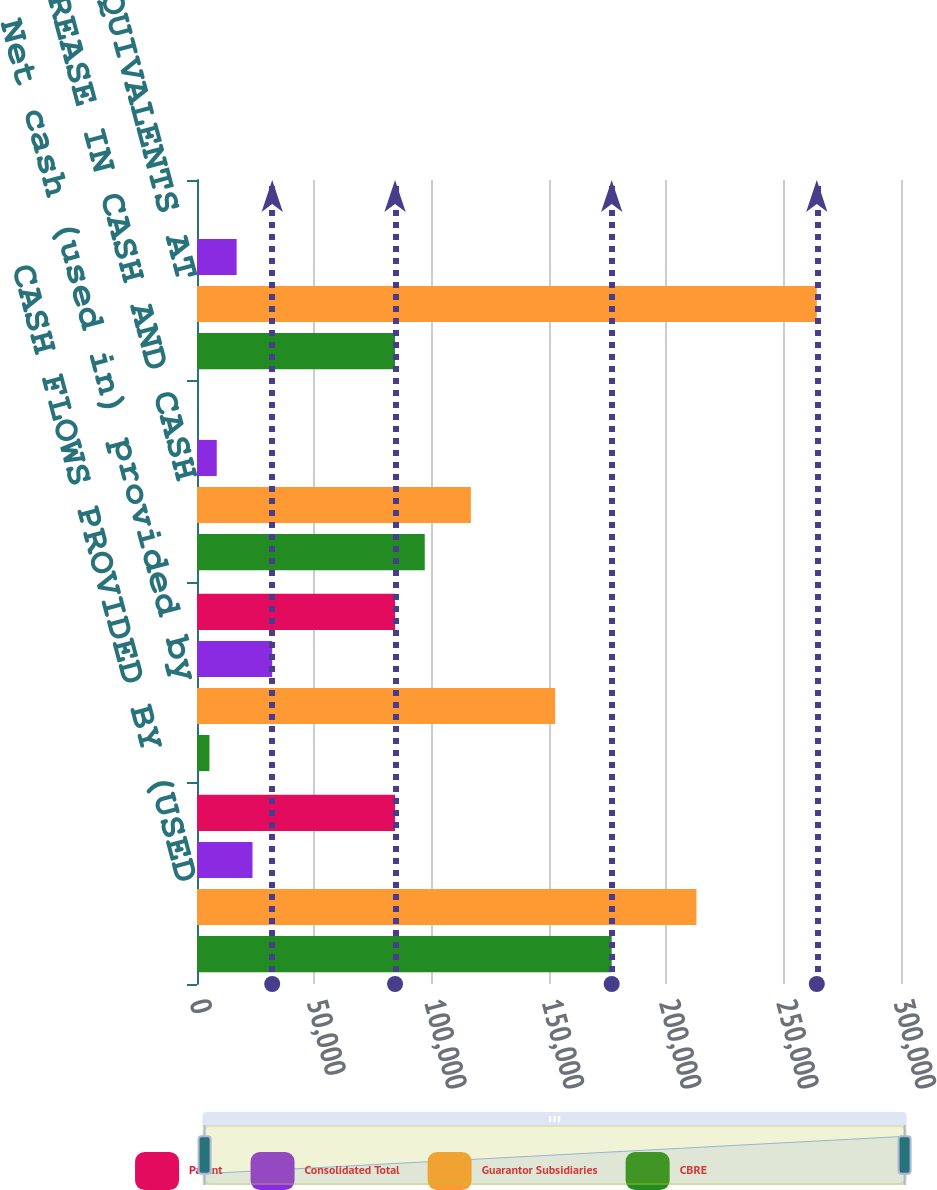Convert chart. <chart><loc_0><loc_0><loc_500><loc_500><stacked_bar_chart><ecel><fcel>CASH FLOWS PROVIDED BY (USED<fcel>Net cash (used in) provided by<fcel>NET INCREASE IN CASH AND CASH<fcel>CASH AND CASH EQUIVALENTS AT<nl><fcel>Parent<fcel>84393<fcel>84391<fcel>2<fcel>7<nl><fcel>Consolidated Total<fcel>23643<fcel>32053<fcel>8410<fcel>16889<nl><fcel>Guarantor Subsidiaries<fcel>212841<fcel>152606<fcel>116711<fcel>264121<nl><fcel>CBRE<fcel>176724<fcel>5301<fcel>97050<fcel>84391<nl></chart> 